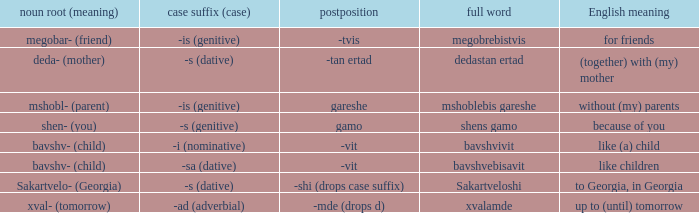What is English Meaning, when Full Word is "Shens Gamo"? Because of you. 